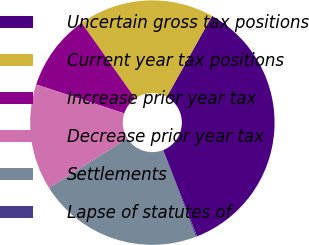<chart> <loc_0><loc_0><loc_500><loc_500><pie_chart><fcel>Uncertain gross tax positions<fcel>Current year tax positions<fcel>Increase prior year tax<fcel>Decrease prior year tax<fcel>Settlements<fcel>Lapse of statutes of<nl><fcel>35.92%<fcel>17.93%<fcel>10.14%<fcel>14.03%<fcel>21.82%<fcel>0.16%<nl></chart> 